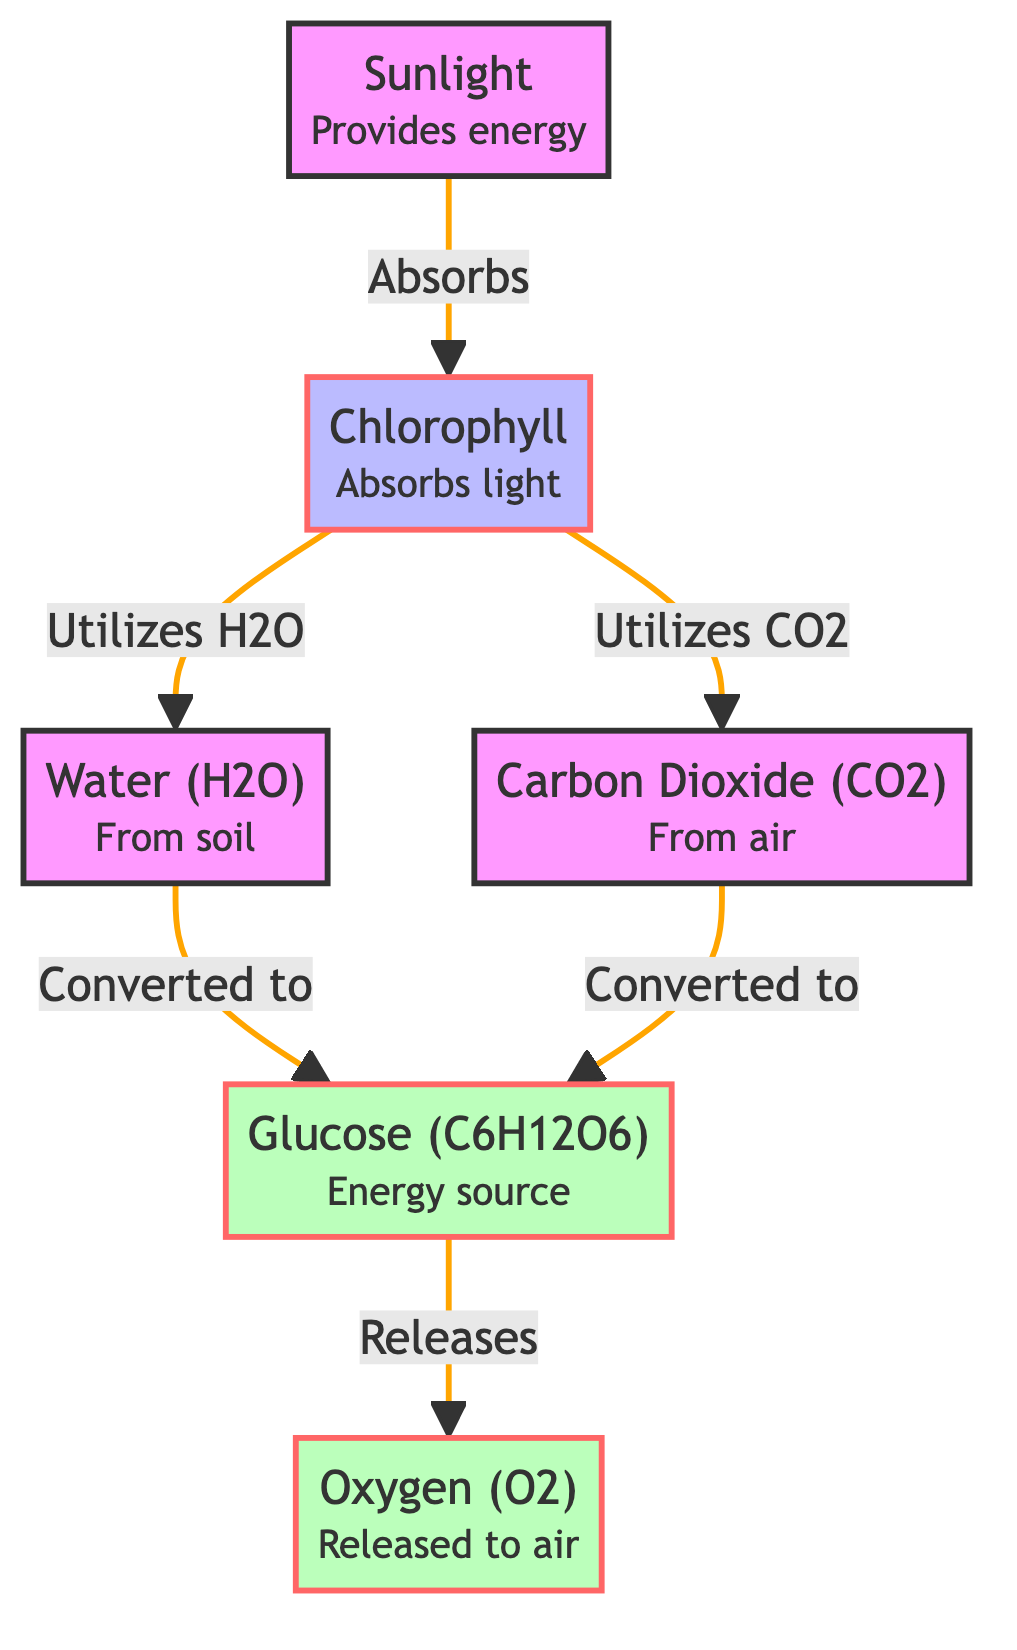What does chlorophyll do in photosynthesis? Chlorophyll absorbs sunlight, which provides the energy needed for the process of photosynthesis. This is indicated directly from the diagram where sunlight is shown as being absorbed by chlorophyll.
Answer: Absorbs light How many outputs are shown in the diagram? The diagram indicates two outputs: glucose and oxygen. By counting the nodes labeled as outputs, we find there are specifically two outputs represented in the flowchart.
Answer: 2 What is the primary energy source produced through photosynthesis? The diagram clearly identifies glucose as the energy source produced during photosynthesis, stemming from the transformation of water and carbon dioxide.
Answer: Glucose Which process utilizes both carbon dioxide and water? The diagram shows that chlorophyll utilizes both carbon dioxide and water to convert them into glucose, indicating this is a key step in the photosynthesis process where both inputs are essential.
Answer: Chlorophyll What is released to the air during photosynthesis? The diagram specifies that oxygen is released to the air as a byproduct of photosynthesis, following the conversion of glucose. This provides a clear understanding of the outputs generated in this natural process.
Answer: Oxygen 